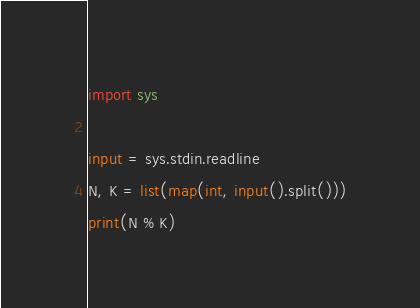Convert code to text. <code><loc_0><loc_0><loc_500><loc_500><_Python_>import sys

input = sys.stdin.readline
N, K = list(map(int, input().split()))
print(N % K)
</code> 